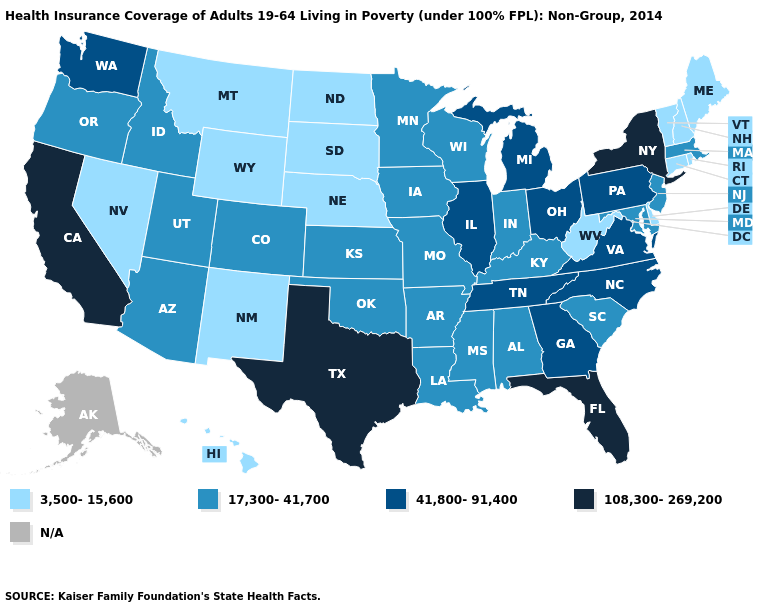What is the value of Arkansas?
Give a very brief answer. 17,300-41,700. Name the states that have a value in the range 108,300-269,200?
Keep it brief. California, Florida, New York, Texas. Which states have the highest value in the USA?
Write a very short answer. California, Florida, New York, Texas. What is the value of Maryland?
Concise answer only. 17,300-41,700. Which states have the lowest value in the USA?
Concise answer only. Connecticut, Delaware, Hawaii, Maine, Montana, Nebraska, Nevada, New Hampshire, New Mexico, North Dakota, Rhode Island, South Dakota, Vermont, West Virginia, Wyoming. What is the lowest value in states that border North Carolina?
Concise answer only. 17,300-41,700. What is the value of Rhode Island?
Answer briefly. 3,500-15,600. What is the value of Georgia?
Answer briefly. 41,800-91,400. What is the highest value in the South ?
Short answer required. 108,300-269,200. Among the states that border Missouri , does Illinois have the highest value?
Answer briefly. Yes. Does Utah have the lowest value in the USA?
Write a very short answer. No. Among the states that border Rhode Island , does Connecticut have the lowest value?
Keep it brief. Yes. Name the states that have a value in the range 108,300-269,200?
Keep it brief. California, Florida, New York, Texas. Does California have the highest value in the USA?
Quick response, please. Yes. 